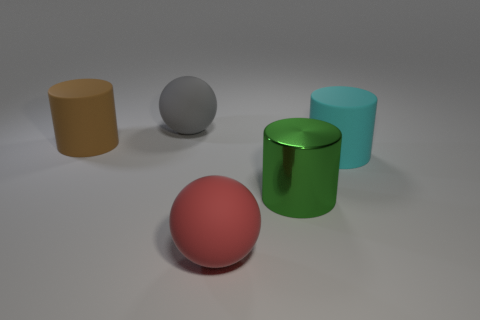Are there any other things that are the same material as the green cylinder?
Your answer should be very brief. No. How many objects are either large shiny things or large red objects?
Offer a very short reply. 2. What is the size of the gray ball?
Your response must be concise. Large. Is the number of brown rubber cylinders less than the number of tiny matte spheres?
Ensure brevity in your answer.  No. How many large rubber cylinders are the same color as the big metallic thing?
Give a very brief answer. 0. Is the color of the big matte object behind the big brown rubber cylinder the same as the large metal cylinder?
Your response must be concise. No. What shape is the thing that is in front of the metallic object?
Offer a terse response. Sphere. Is there a large cyan matte cylinder that is left of the brown thing that is behind the big red sphere?
Give a very brief answer. No. How many small cyan things have the same material as the large gray sphere?
Make the answer very short. 0. There is a matte sphere that is in front of the large rubber cylinder in front of the matte cylinder that is left of the large gray ball; what size is it?
Your answer should be compact. Large. 